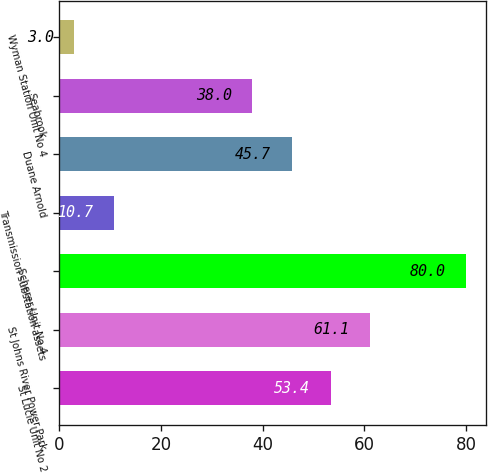Convert chart. <chart><loc_0><loc_0><loc_500><loc_500><bar_chart><fcel>St Lucie Unit No 2<fcel>St Johns River Power Park<fcel>Scherer Unit No 4<fcel>Transmission substation assets<fcel>Duane Arnold<fcel>Seabrook<fcel>Wyman Station Unit No 4<nl><fcel>53.4<fcel>61.1<fcel>80<fcel>10.7<fcel>45.7<fcel>38<fcel>3<nl></chart> 